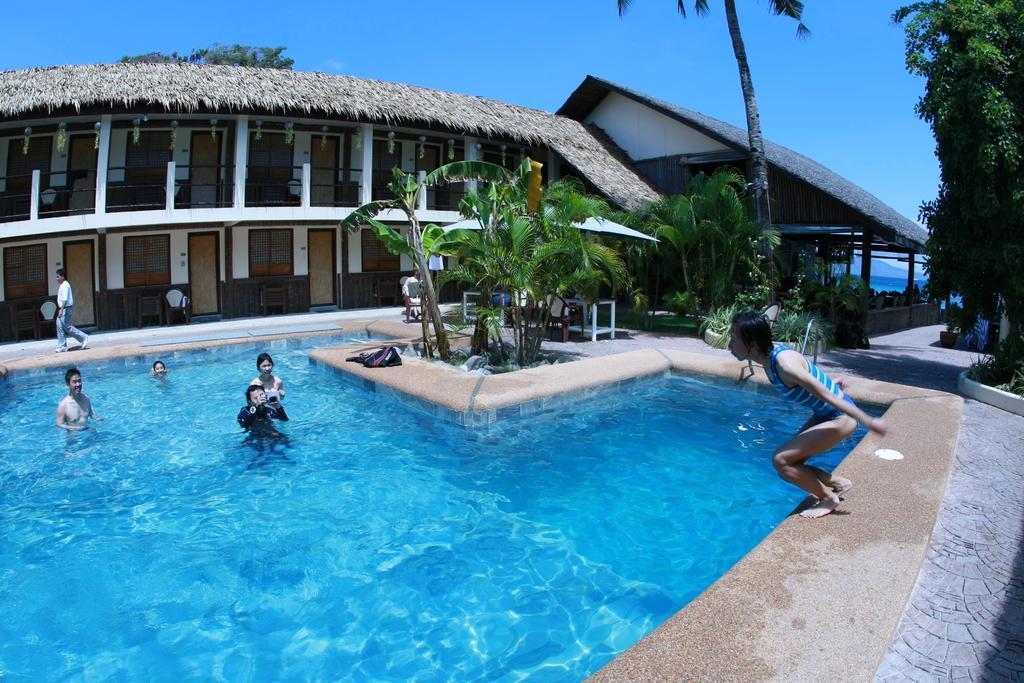Could you give a brief overview of what you see in this image? In this image we can see a few people, some of them are in the swimming pool, there is a towel on the floor, there are houses, doors, windows, plants, trees, also we can see the sky. 